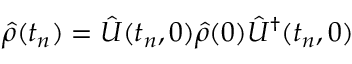Convert formula to latex. <formula><loc_0><loc_0><loc_500><loc_500>\begin{array} { r } { \hat { \rho } ( t _ { n } ) = \hat { U } ( t _ { n } , 0 ) \hat { \rho } ( 0 ) \hat { U } ^ { \dagger } ( t _ { n } , 0 ) } \end{array}</formula> 